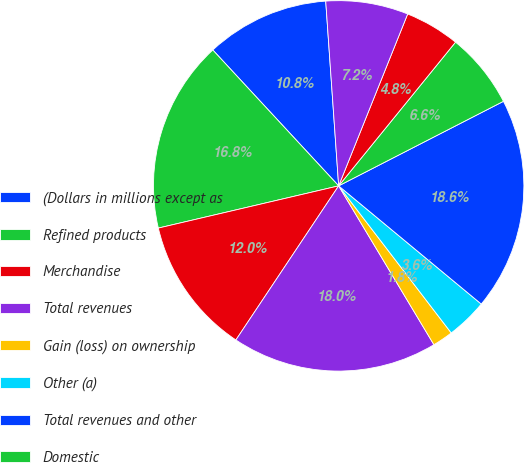Convert chart. <chart><loc_0><loc_0><loc_500><loc_500><pie_chart><fcel>(Dollars in millions except as<fcel>Refined products<fcel>Merchandise<fcel>Total revenues<fcel>Gain (loss) on ownership<fcel>Other (a)<fcel>Total revenues and other<fcel>Domestic<fcel>International<fcel>E&P segment income<nl><fcel>10.78%<fcel>16.77%<fcel>11.98%<fcel>17.96%<fcel>1.8%<fcel>3.59%<fcel>18.56%<fcel>6.59%<fcel>4.79%<fcel>7.19%<nl></chart> 